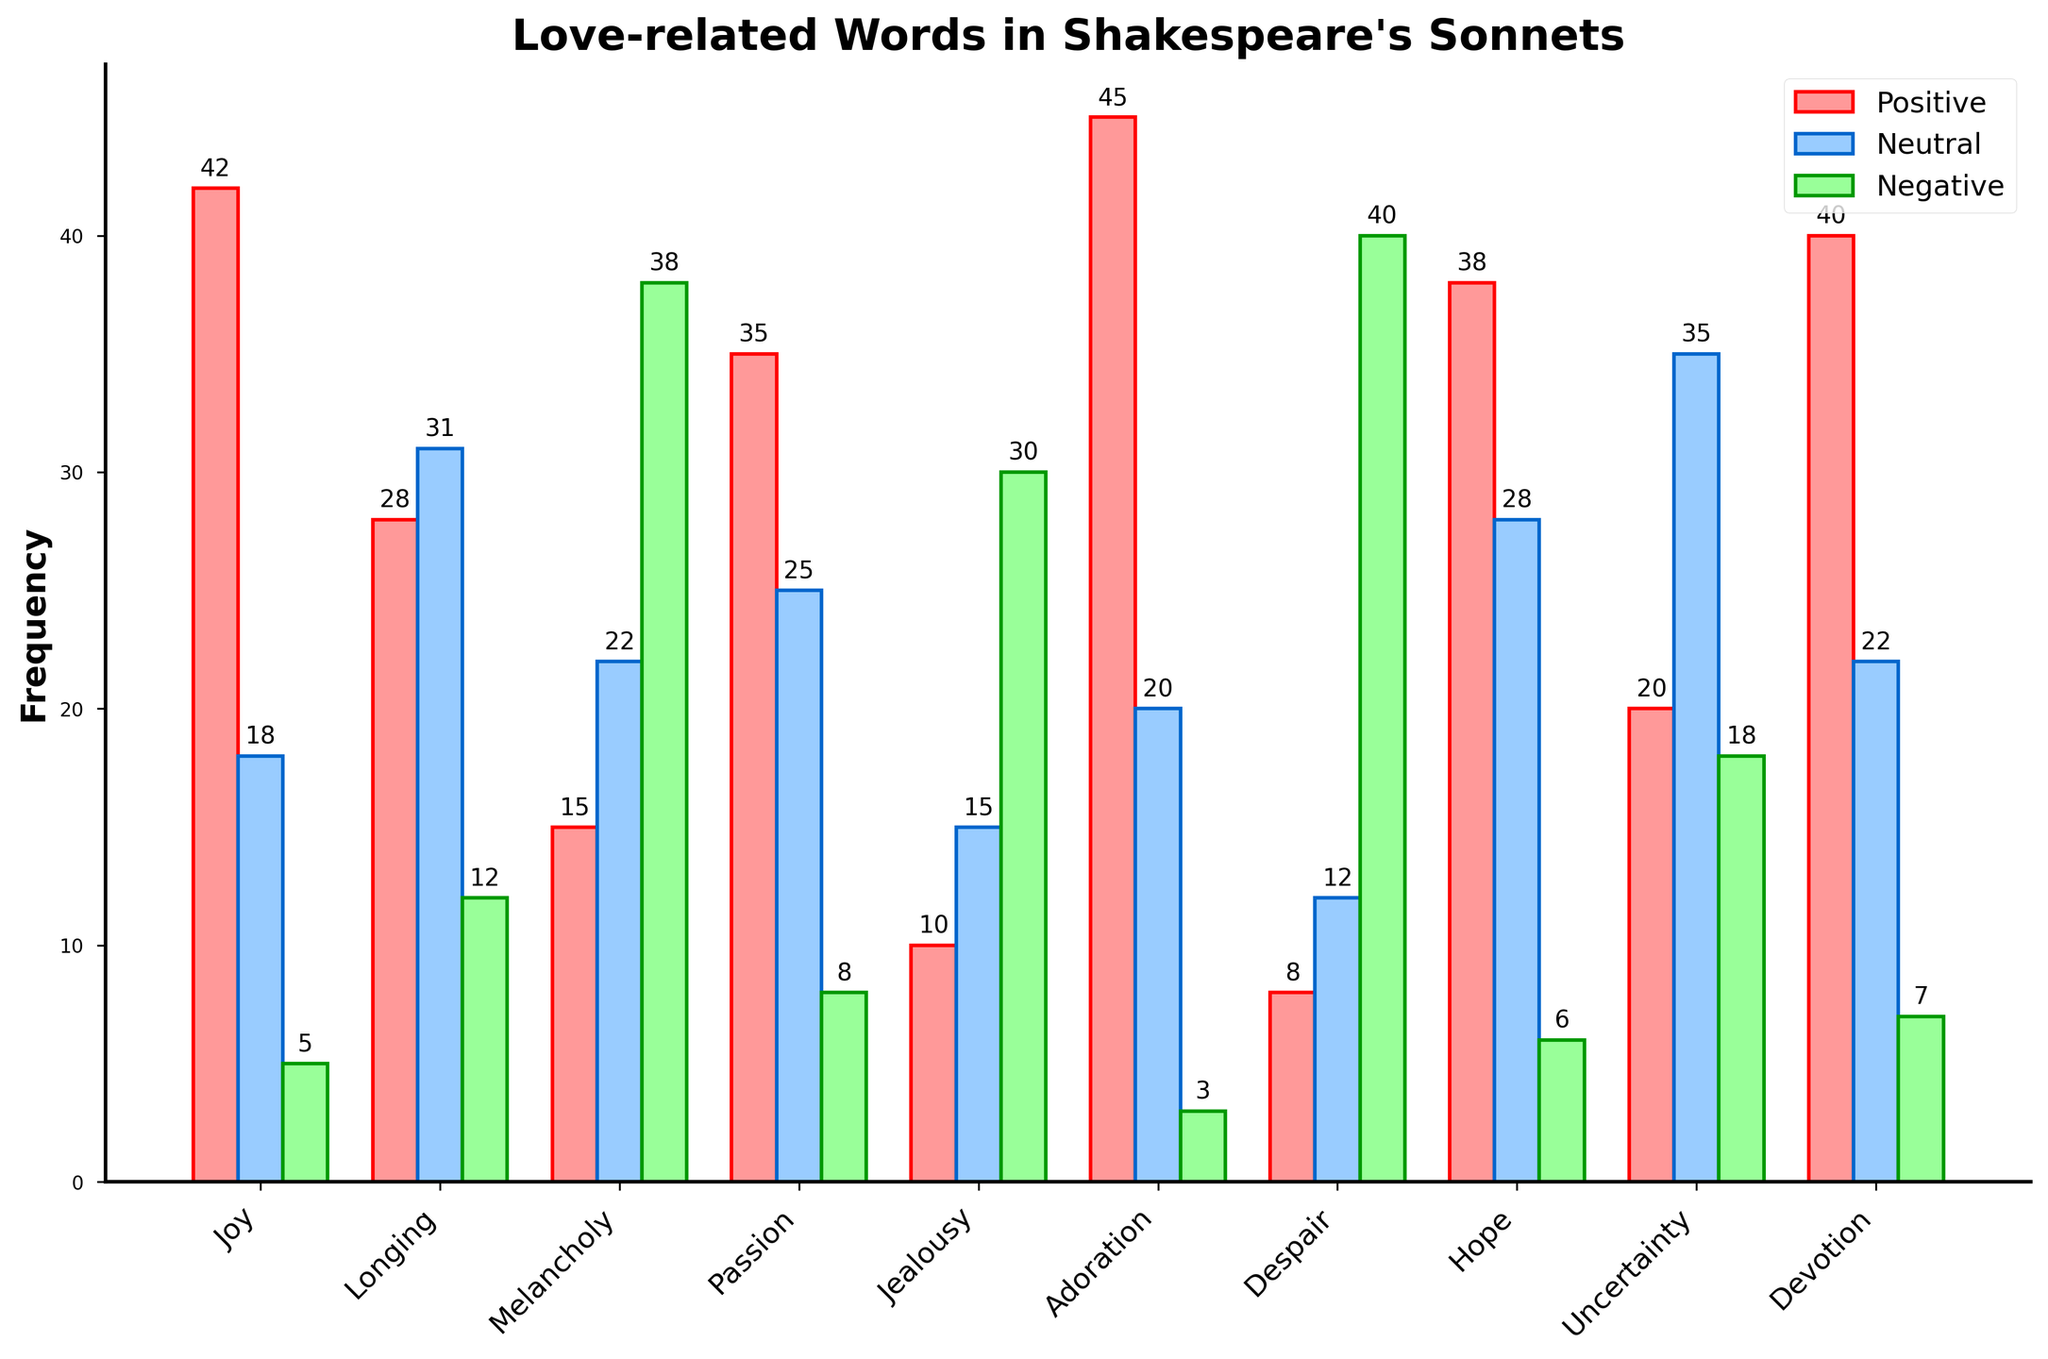Which emotional tone has the highest frequency of neutral love words? We need to look at the bar representing neutral love words for each emotional tone. The highest bar in blue corresponds to "Uncertainty" with a frequency of 35.
Answer: Uncertainty What is the difference in frequency between positive and negative love words for the tone "Despair"? For "Despair", the positive love words frequency is 8, and the negative love words frequency is 40. The difference is calculated as 40 - 8 = 32.
Answer: 32 Which emotional tone has equal frequencies of positive love words and negative love words? We need to find an emotional tone where the red and green bars are at the same height. None of the tones have equal frequencies for positive and negative love words.
Answer: None How many more positive love words are there in "Adoration" compared to "Jealousy"? The number of positive love words in "Adoration" is 45, and in "Jealousy" is 10. Subtract 10 from 45 to get 35.
Answer: 35 What is the average frequency of neutral love words in "Passion", "Joy", and "Devotion"? The frequencies are 25 for "Passion", 18 for "Joy", and 22 for "Devotion". Sum them up: 25 + 18 + 22 = 65. Then divide by 3: 65 / 3 ≈ 21.67.
Answer: 21.67 Which emotional tone has the lowest frequency of positive love words? The smallest red bar represents "Despair" with a frequency of 8.
Answer: Despair Compare the frequencies of positive and negative love words for "Melancholy". Which is higher? The positive love words frequency for "Melancholy" is 15, and the negative love words frequency is 38. 38 is higher than 15.
Answer: Negative love words What is the sum of the frequencies of negative love words across all emotional tones? Add up all the frequencies for the green bars: 5 + 12 + 38 + 8 + 30 + 3 + 40 + 6 + 18 + 7 = 167.
Answer: 167 Which emotional tone has more positive love words, "Hope" or "Devotion"? By comparing the heights of the red bars for "Hope" (38) and "Devotion" (40), we see that "Devotion" has more positive love words.
Answer: Devotion In which emotional tone does the frequency of neutral love words exceed the combined frequency of positive and negative love words? For "Longing", neutral love words (31) exceed the sum of positive (28) and negative (12) love words. The calculation is 28 + 12 = 40, which is not exceeded by 31. So, identify that in all others, the part exceeding some combined frequency doesn’t occur. None of the emotional tones satisfy this condition.
Answer: None 